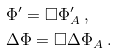<formula> <loc_0><loc_0><loc_500><loc_500>& \Phi ^ { \prime } = \Box \Phi _ { A } ^ { \prime } \ , \\ & \Delta \Phi = \Box \Delta \Phi _ { A } \ .</formula> 